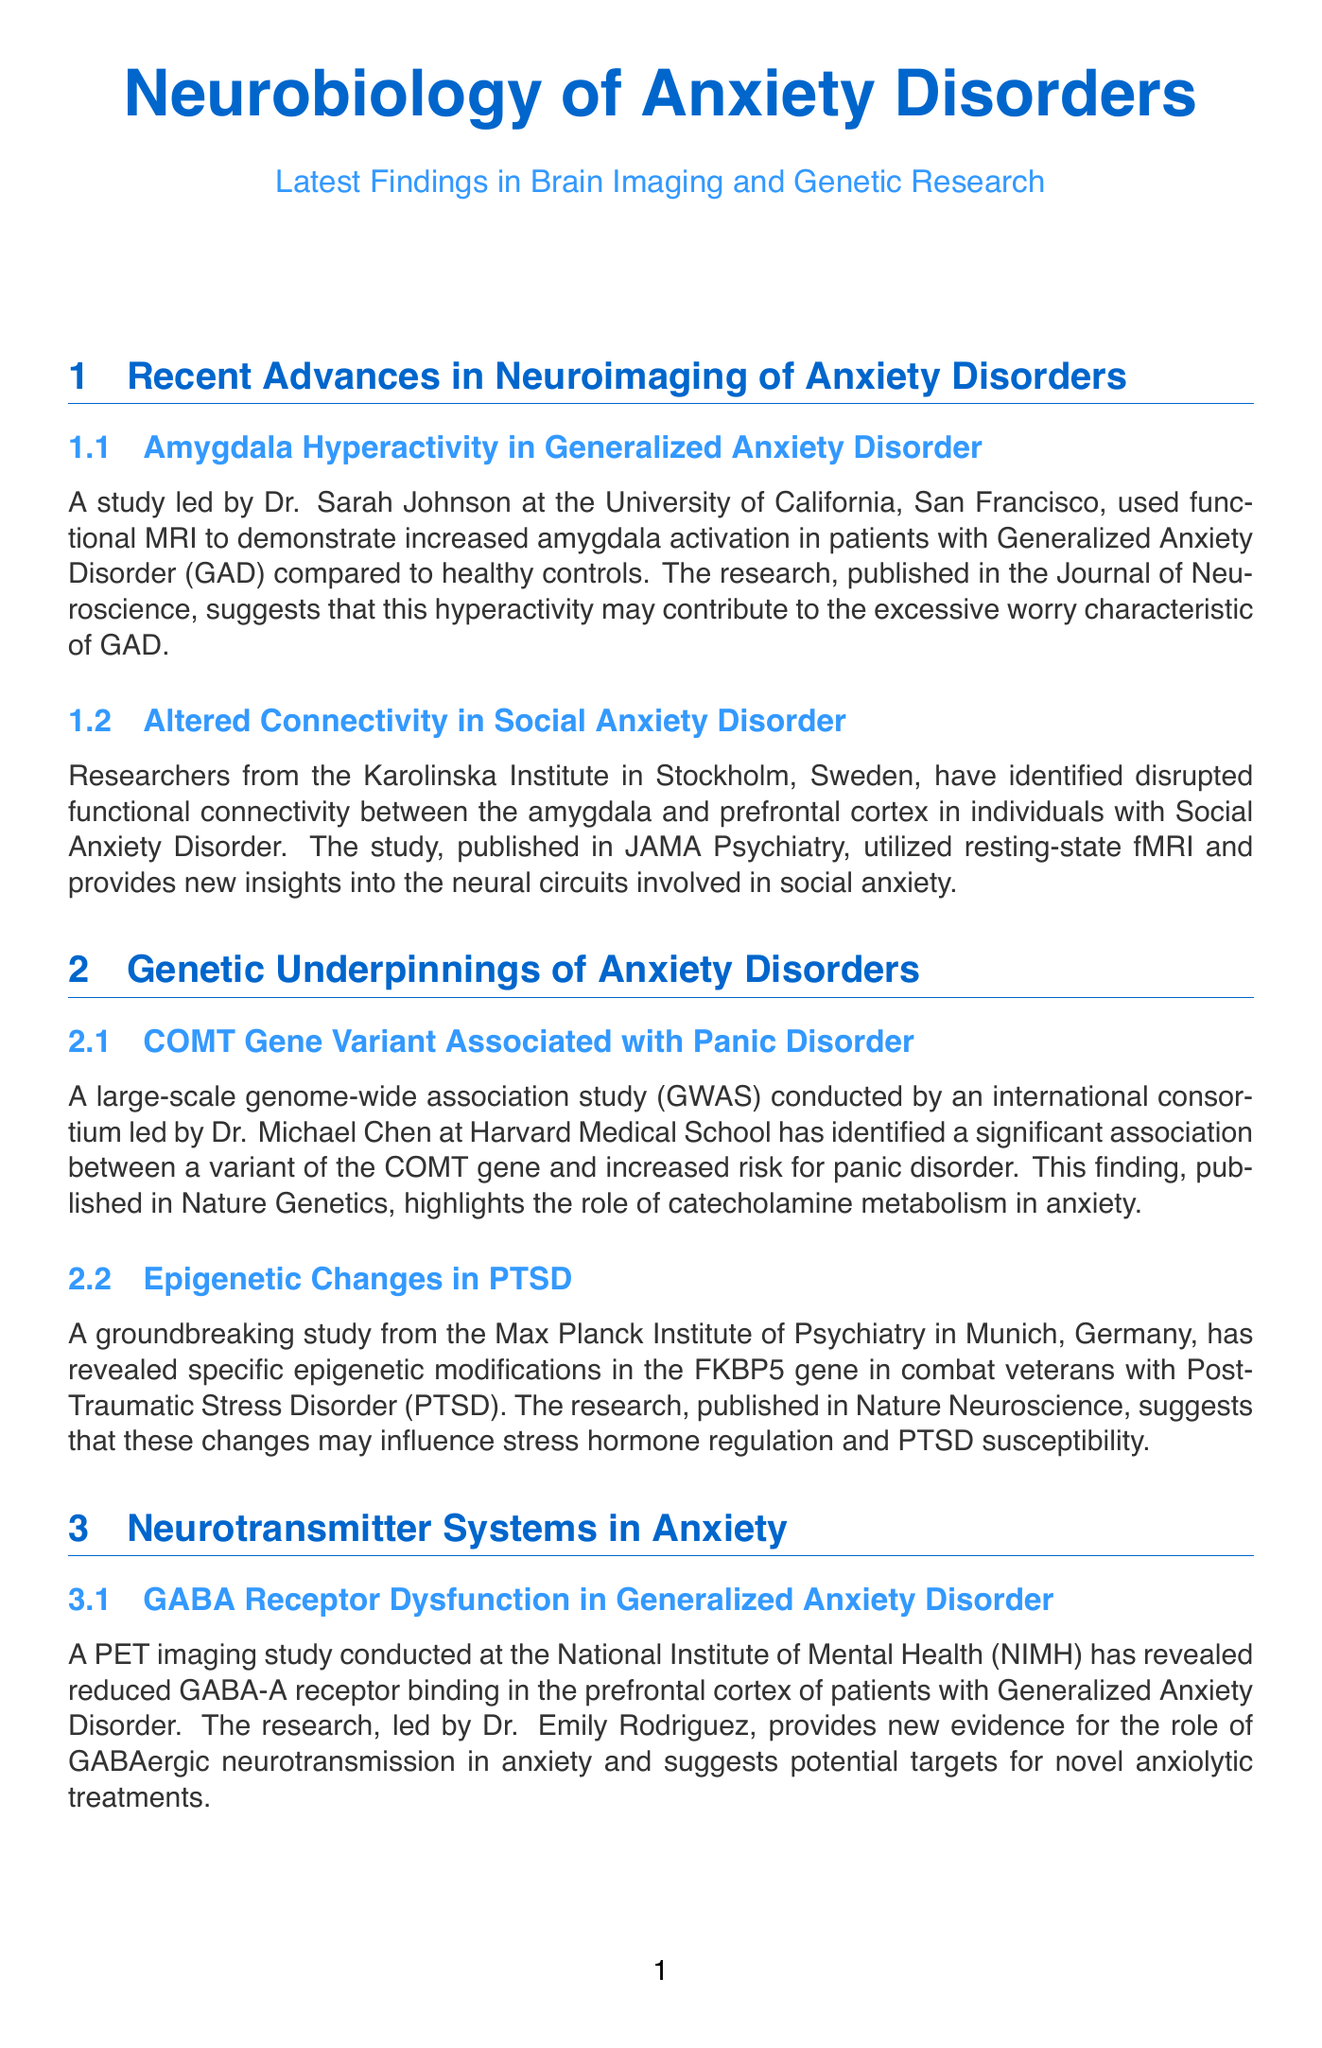what study identified increased amygdala activation in GAD? The study led by Dr. Sarah Johnson at the University of California, San Francisco, identified increased amygdala activation in patients with Generalized Anxiety Disorder.
Answer: Dr. Sarah Johnson what genetic variant is associated with panic disorder? A large-scale genome-wide association study identified a variant of the COMT gene associated with increased risk for panic disorder.
Answer: COMT gene variant which neurotransmitter receptor showed reduced binding in GAD patients? A PET imaging study revealed reduced GABA-A receptor binding in the prefrontal cortex of patients with Generalized Anxiety Disorder.
Answer: GABA-A receptor which gene showed epigenetic changes in PTSD combat veterans? The FKBP5 gene showed specific epigenetic modifications in combat veterans with Post-Traumatic Stress Disorder.
Answer: FKBP5 gene what research technique was used in the study on anxiety circuits at MIT? Researchers at MIT used optogenetic techniques to selectively activate and inhibit specific neural circuits involved in anxiety-like behaviors.
Answer: optogenetic techniques in which journal was the amygdala hyperactivity study published? The research on amygdala hyperactivity in GAD was published in the Journal of Neuroscience.
Answer: Journal of Neuroscience what is the focus of Dr. Lisa Thompson's clinical trial? Dr. Lisa Thompson's clinical trial is exploring the use of genetic and neuroimaging biomarkers to predict treatment response in anxiety disorders.
Answer: genetic and neuroimaging biomarkers what was the publication for the study on serotonin transporter gene polymorphisms? The research identifying serotonin transporter gene polymorphisms associated with increased anxiety sensitivity was published in Molecular Psychiatry.
Answer: Molecular Psychiatry 